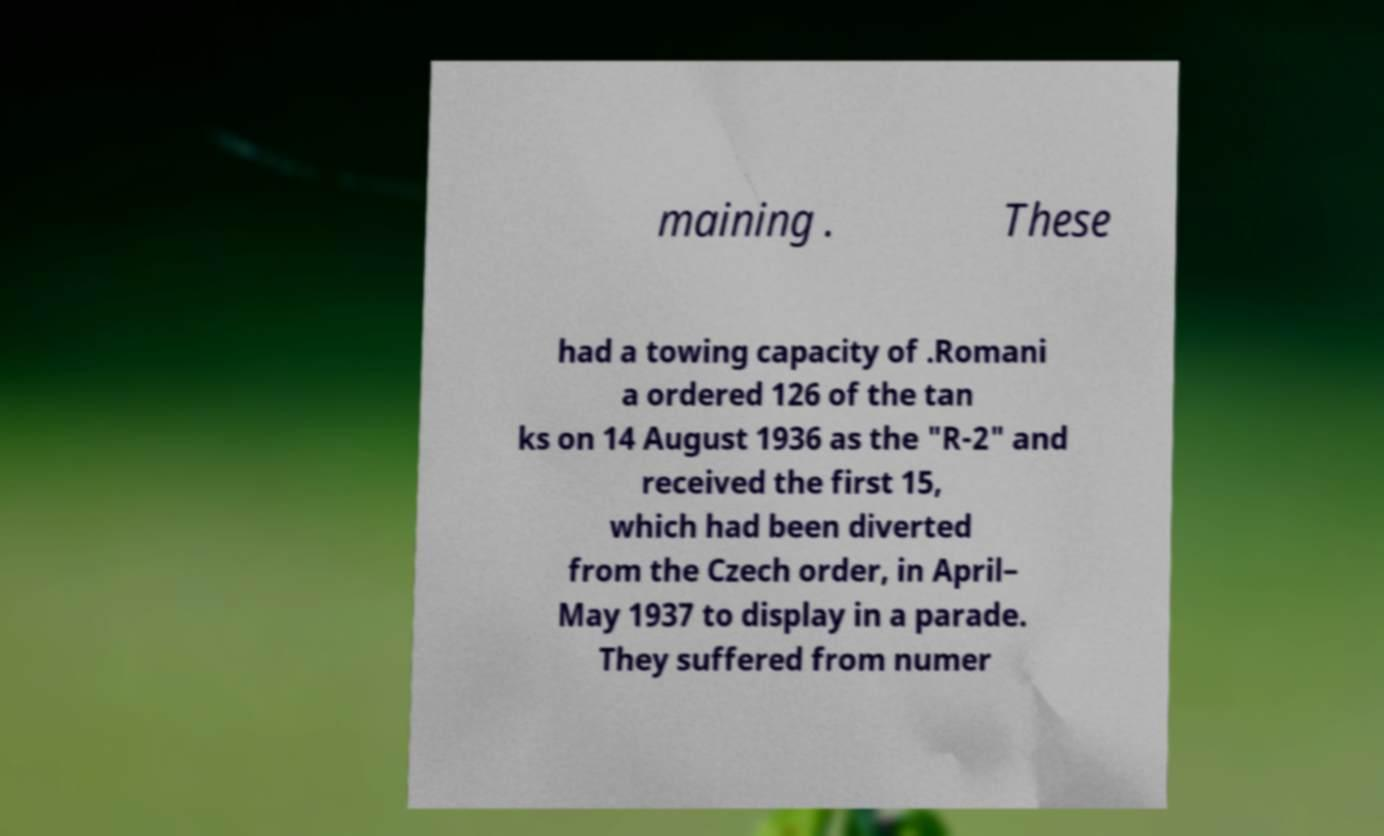Please read and relay the text visible in this image. What does it say? maining . These had a towing capacity of .Romani a ordered 126 of the tan ks on 14 August 1936 as the "R-2" and received the first 15, which had been diverted from the Czech order, in April– May 1937 to display in a parade. They suffered from numer 